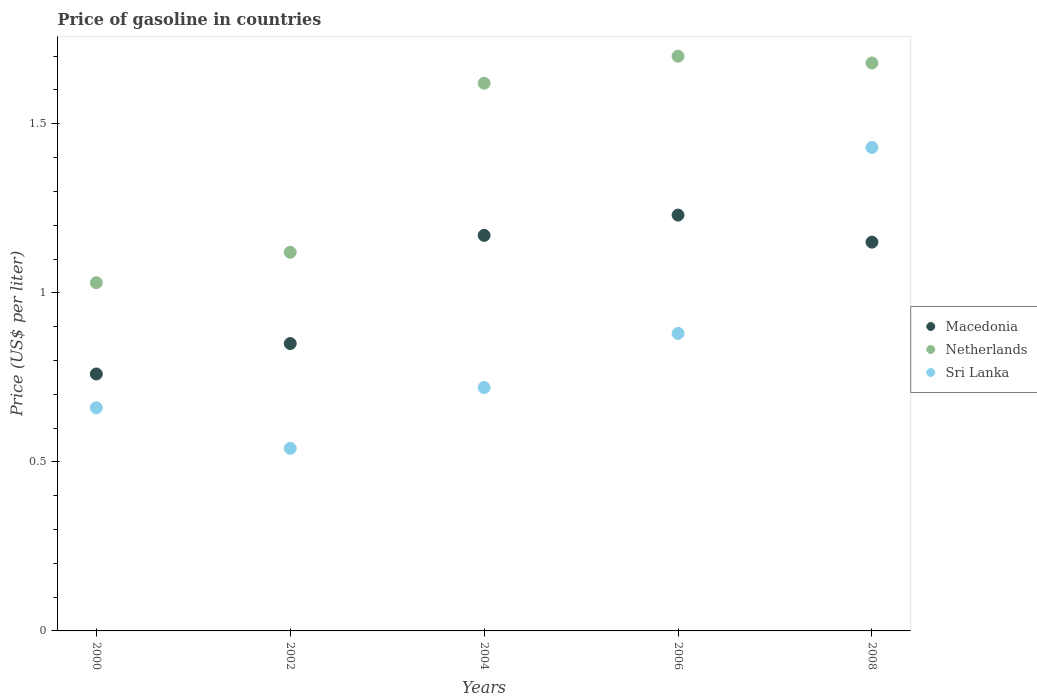What is the price of gasoline in Netherlands in 2000?
Offer a very short reply. 1.03. Across all years, what is the maximum price of gasoline in Netherlands?
Provide a short and direct response. 1.7. In which year was the price of gasoline in Netherlands maximum?
Provide a short and direct response. 2006. In which year was the price of gasoline in Netherlands minimum?
Give a very brief answer. 2000. What is the total price of gasoline in Netherlands in the graph?
Give a very brief answer. 7.15. What is the difference between the price of gasoline in Macedonia in 2002 and that in 2004?
Give a very brief answer. -0.32. What is the difference between the price of gasoline in Macedonia in 2002 and the price of gasoline in Sri Lanka in 2008?
Offer a terse response. -0.58. What is the average price of gasoline in Sri Lanka per year?
Offer a terse response. 0.85. In the year 2000, what is the difference between the price of gasoline in Macedonia and price of gasoline in Sri Lanka?
Provide a succinct answer. 0.1. In how many years, is the price of gasoline in Sri Lanka greater than 0.9 US$?
Keep it short and to the point. 1. What is the ratio of the price of gasoline in Macedonia in 2002 to that in 2008?
Make the answer very short. 0.74. Is the difference between the price of gasoline in Macedonia in 2000 and 2004 greater than the difference between the price of gasoline in Sri Lanka in 2000 and 2004?
Provide a short and direct response. No. What is the difference between the highest and the second highest price of gasoline in Macedonia?
Ensure brevity in your answer.  0.06. What is the difference between the highest and the lowest price of gasoline in Sri Lanka?
Ensure brevity in your answer.  0.89. Is the sum of the price of gasoline in Netherlands in 2000 and 2006 greater than the maximum price of gasoline in Sri Lanka across all years?
Offer a terse response. Yes. Is it the case that in every year, the sum of the price of gasoline in Sri Lanka and price of gasoline in Netherlands  is greater than the price of gasoline in Macedonia?
Make the answer very short. Yes. Does the price of gasoline in Sri Lanka monotonically increase over the years?
Your response must be concise. No. How many dotlines are there?
Provide a succinct answer. 3. Are the values on the major ticks of Y-axis written in scientific E-notation?
Offer a very short reply. No. Where does the legend appear in the graph?
Ensure brevity in your answer.  Center right. What is the title of the graph?
Your answer should be compact. Price of gasoline in countries. What is the label or title of the Y-axis?
Keep it short and to the point. Price (US$ per liter). What is the Price (US$ per liter) of Macedonia in 2000?
Your response must be concise. 0.76. What is the Price (US$ per liter) in Netherlands in 2000?
Keep it short and to the point. 1.03. What is the Price (US$ per liter) in Sri Lanka in 2000?
Ensure brevity in your answer.  0.66. What is the Price (US$ per liter) of Macedonia in 2002?
Provide a short and direct response. 0.85. What is the Price (US$ per liter) in Netherlands in 2002?
Keep it short and to the point. 1.12. What is the Price (US$ per liter) of Sri Lanka in 2002?
Give a very brief answer. 0.54. What is the Price (US$ per liter) in Macedonia in 2004?
Give a very brief answer. 1.17. What is the Price (US$ per liter) of Netherlands in 2004?
Ensure brevity in your answer.  1.62. What is the Price (US$ per liter) in Sri Lanka in 2004?
Provide a short and direct response. 0.72. What is the Price (US$ per liter) in Macedonia in 2006?
Make the answer very short. 1.23. What is the Price (US$ per liter) of Sri Lanka in 2006?
Make the answer very short. 0.88. What is the Price (US$ per liter) in Macedonia in 2008?
Keep it short and to the point. 1.15. What is the Price (US$ per liter) of Netherlands in 2008?
Offer a terse response. 1.68. What is the Price (US$ per liter) in Sri Lanka in 2008?
Give a very brief answer. 1.43. Across all years, what is the maximum Price (US$ per liter) of Macedonia?
Your answer should be very brief. 1.23. Across all years, what is the maximum Price (US$ per liter) of Sri Lanka?
Keep it short and to the point. 1.43. Across all years, what is the minimum Price (US$ per liter) of Macedonia?
Make the answer very short. 0.76. Across all years, what is the minimum Price (US$ per liter) of Sri Lanka?
Offer a very short reply. 0.54. What is the total Price (US$ per liter) of Macedonia in the graph?
Keep it short and to the point. 5.16. What is the total Price (US$ per liter) of Netherlands in the graph?
Your answer should be compact. 7.15. What is the total Price (US$ per liter) of Sri Lanka in the graph?
Your response must be concise. 4.23. What is the difference between the Price (US$ per liter) of Macedonia in 2000 and that in 2002?
Keep it short and to the point. -0.09. What is the difference between the Price (US$ per liter) in Netherlands in 2000 and that in 2002?
Give a very brief answer. -0.09. What is the difference between the Price (US$ per liter) in Sri Lanka in 2000 and that in 2002?
Offer a very short reply. 0.12. What is the difference between the Price (US$ per liter) of Macedonia in 2000 and that in 2004?
Your answer should be compact. -0.41. What is the difference between the Price (US$ per liter) of Netherlands in 2000 and that in 2004?
Your response must be concise. -0.59. What is the difference between the Price (US$ per liter) in Sri Lanka in 2000 and that in 2004?
Give a very brief answer. -0.06. What is the difference between the Price (US$ per liter) in Macedonia in 2000 and that in 2006?
Provide a succinct answer. -0.47. What is the difference between the Price (US$ per liter) in Netherlands in 2000 and that in 2006?
Provide a succinct answer. -0.67. What is the difference between the Price (US$ per liter) in Sri Lanka in 2000 and that in 2006?
Provide a short and direct response. -0.22. What is the difference between the Price (US$ per liter) in Macedonia in 2000 and that in 2008?
Keep it short and to the point. -0.39. What is the difference between the Price (US$ per liter) in Netherlands in 2000 and that in 2008?
Make the answer very short. -0.65. What is the difference between the Price (US$ per liter) of Sri Lanka in 2000 and that in 2008?
Make the answer very short. -0.77. What is the difference between the Price (US$ per liter) in Macedonia in 2002 and that in 2004?
Offer a terse response. -0.32. What is the difference between the Price (US$ per liter) of Sri Lanka in 2002 and that in 2004?
Offer a very short reply. -0.18. What is the difference between the Price (US$ per liter) in Macedonia in 2002 and that in 2006?
Offer a terse response. -0.38. What is the difference between the Price (US$ per liter) of Netherlands in 2002 and that in 2006?
Your answer should be very brief. -0.58. What is the difference between the Price (US$ per liter) in Sri Lanka in 2002 and that in 2006?
Your answer should be very brief. -0.34. What is the difference between the Price (US$ per liter) of Netherlands in 2002 and that in 2008?
Your answer should be compact. -0.56. What is the difference between the Price (US$ per liter) of Sri Lanka in 2002 and that in 2008?
Give a very brief answer. -0.89. What is the difference between the Price (US$ per liter) of Macedonia in 2004 and that in 2006?
Keep it short and to the point. -0.06. What is the difference between the Price (US$ per liter) in Netherlands in 2004 and that in 2006?
Provide a succinct answer. -0.08. What is the difference between the Price (US$ per liter) of Sri Lanka in 2004 and that in 2006?
Your answer should be compact. -0.16. What is the difference between the Price (US$ per liter) of Netherlands in 2004 and that in 2008?
Your answer should be very brief. -0.06. What is the difference between the Price (US$ per liter) in Sri Lanka in 2004 and that in 2008?
Your answer should be compact. -0.71. What is the difference between the Price (US$ per liter) of Macedonia in 2006 and that in 2008?
Offer a very short reply. 0.08. What is the difference between the Price (US$ per liter) in Netherlands in 2006 and that in 2008?
Your answer should be very brief. 0.02. What is the difference between the Price (US$ per liter) in Sri Lanka in 2006 and that in 2008?
Offer a very short reply. -0.55. What is the difference between the Price (US$ per liter) of Macedonia in 2000 and the Price (US$ per liter) of Netherlands in 2002?
Give a very brief answer. -0.36. What is the difference between the Price (US$ per liter) in Macedonia in 2000 and the Price (US$ per liter) in Sri Lanka in 2002?
Ensure brevity in your answer.  0.22. What is the difference between the Price (US$ per liter) in Netherlands in 2000 and the Price (US$ per liter) in Sri Lanka in 2002?
Make the answer very short. 0.49. What is the difference between the Price (US$ per liter) of Macedonia in 2000 and the Price (US$ per liter) of Netherlands in 2004?
Give a very brief answer. -0.86. What is the difference between the Price (US$ per liter) of Netherlands in 2000 and the Price (US$ per liter) of Sri Lanka in 2004?
Ensure brevity in your answer.  0.31. What is the difference between the Price (US$ per liter) of Macedonia in 2000 and the Price (US$ per liter) of Netherlands in 2006?
Ensure brevity in your answer.  -0.94. What is the difference between the Price (US$ per liter) in Macedonia in 2000 and the Price (US$ per liter) in Sri Lanka in 2006?
Offer a very short reply. -0.12. What is the difference between the Price (US$ per liter) of Macedonia in 2000 and the Price (US$ per liter) of Netherlands in 2008?
Offer a very short reply. -0.92. What is the difference between the Price (US$ per liter) in Macedonia in 2000 and the Price (US$ per liter) in Sri Lanka in 2008?
Make the answer very short. -0.67. What is the difference between the Price (US$ per liter) of Macedonia in 2002 and the Price (US$ per liter) of Netherlands in 2004?
Keep it short and to the point. -0.77. What is the difference between the Price (US$ per liter) in Macedonia in 2002 and the Price (US$ per liter) in Sri Lanka in 2004?
Make the answer very short. 0.13. What is the difference between the Price (US$ per liter) of Netherlands in 2002 and the Price (US$ per liter) of Sri Lanka in 2004?
Give a very brief answer. 0.4. What is the difference between the Price (US$ per liter) of Macedonia in 2002 and the Price (US$ per liter) of Netherlands in 2006?
Give a very brief answer. -0.85. What is the difference between the Price (US$ per liter) in Macedonia in 2002 and the Price (US$ per liter) in Sri Lanka in 2006?
Your answer should be compact. -0.03. What is the difference between the Price (US$ per liter) of Netherlands in 2002 and the Price (US$ per liter) of Sri Lanka in 2006?
Offer a terse response. 0.24. What is the difference between the Price (US$ per liter) of Macedonia in 2002 and the Price (US$ per liter) of Netherlands in 2008?
Your response must be concise. -0.83. What is the difference between the Price (US$ per liter) of Macedonia in 2002 and the Price (US$ per liter) of Sri Lanka in 2008?
Ensure brevity in your answer.  -0.58. What is the difference between the Price (US$ per liter) in Netherlands in 2002 and the Price (US$ per liter) in Sri Lanka in 2008?
Your response must be concise. -0.31. What is the difference between the Price (US$ per liter) in Macedonia in 2004 and the Price (US$ per liter) in Netherlands in 2006?
Ensure brevity in your answer.  -0.53. What is the difference between the Price (US$ per liter) in Macedonia in 2004 and the Price (US$ per liter) in Sri Lanka in 2006?
Make the answer very short. 0.29. What is the difference between the Price (US$ per liter) in Netherlands in 2004 and the Price (US$ per liter) in Sri Lanka in 2006?
Your answer should be very brief. 0.74. What is the difference between the Price (US$ per liter) in Macedonia in 2004 and the Price (US$ per liter) in Netherlands in 2008?
Offer a very short reply. -0.51. What is the difference between the Price (US$ per liter) in Macedonia in 2004 and the Price (US$ per liter) in Sri Lanka in 2008?
Your response must be concise. -0.26. What is the difference between the Price (US$ per liter) of Netherlands in 2004 and the Price (US$ per liter) of Sri Lanka in 2008?
Provide a succinct answer. 0.19. What is the difference between the Price (US$ per liter) in Macedonia in 2006 and the Price (US$ per liter) in Netherlands in 2008?
Your answer should be compact. -0.45. What is the difference between the Price (US$ per liter) in Netherlands in 2006 and the Price (US$ per liter) in Sri Lanka in 2008?
Offer a terse response. 0.27. What is the average Price (US$ per liter) in Macedonia per year?
Your response must be concise. 1.03. What is the average Price (US$ per liter) in Netherlands per year?
Provide a succinct answer. 1.43. What is the average Price (US$ per liter) in Sri Lanka per year?
Your answer should be very brief. 0.85. In the year 2000, what is the difference between the Price (US$ per liter) of Macedonia and Price (US$ per liter) of Netherlands?
Provide a short and direct response. -0.27. In the year 2000, what is the difference between the Price (US$ per liter) in Netherlands and Price (US$ per liter) in Sri Lanka?
Ensure brevity in your answer.  0.37. In the year 2002, what is the difference between the Price (US$ per liter) in Macedonia and Price (US$ per liter) in Netherlands?
Provide a succinct answer. -0.27. In the year 2002, what is the difference between the Price (US$ per liter) of Macedonia and Price (US$ per liter) of Sri Lanka?
Provide a short and direct response. 0.31. In the year 2002, what is the difference between the Price (US$ per liter) of Netherlands and Price (US$ per liter) of Sri Lanka?
Provide a succinct answer. 0.58. In the year 2004, what is the difference between the Price (US$ per liter) in Macedonia and Price (US$ per liter) in Netherlands?
Your answer should be compact. -0.45. In the year 2004, what is the difference between the Price (US$ per liter) of Macedonia and Price (US$ per liter) of Sri Lanka?
Give a very brief answer. 0.45. In the year 2006, what is the difference between the Price (US$ per liter) of Macedonia and Price (US$ per liter) of Netherlands?
Your answer should be very brief. -0.47. In the year 2006, what is the difference between the Price (US$ per liter) in Netherlands and Price (US$ per liter) in Sri Lanka?
Provide a short and direct response. 0.82. In the year 2008, what is the difference between the Price (US$ per liter) of Macedonia and Price (US$ per liter) of Netherlands?
Provide a succinct answer. -0.53. In the year 2008, what is the difference between the Price (US$ per liter) in Macedonia and Price (US$ per liter) in Sri Lanka?
Make the answer very short. -0.28. In the year 2008, what is the difference between the Price (US$ per liter) of Netherlands and Price (US$ per liter) of Sri Lanka?
Keep it short and to the point. 0.25. What is the ratio of the Price (US$ per liter) of Macedonia in 2000 to that in 2002?
Your response must be concise. 0.89. What is the ratio of the Price (US$ per liter) of Netherlands in 2000 to that in 2002?
Make the answer very short. 0.92. What is the ratio of the Price (US$ per liter) in Sri Lanka in 2000 to that in 2002?
Make the answer very short. 1.22. What is the ratio of the Price (US$ per liter) in Macedonia in 2000 to that in 2004?
Your response must be concise. 0.65. What is the ratio of the Price (US$ per liter) in Netherlands in 2000 to that in 2004?
Give a very brief answer. 0.64. What is the ratio of the Price (US$ per liter) of Sri Lanka in 2000 to that in 2004?
Keep it short and to the point. 0.92. What is the ratio of the Price (US$ per liter) in Macedonia in 2000 to that in 2006?
Make the answer very short. 0.62. What is the ratio of the Price (US$ per liter) of Netherlands in 2000 to that in 2006?
Your answer should be very brief. 0.61. What is the ratio of the Price (US$ per liter) of Sri Lanka in 2000 to that in 2006?
Your answer should be very brief. 0.75. What is the ratio of the Price (US$ per liter) of Macedonia in 2000 to that in 2008?
Your response must be concise. 0.66. What is the ratio of the Price (US$ per liter) of Netherlands in 2000 to that in 2008?
Provide a short and direct response. 0.61. What is the ratio of the Price (US$ per liter) of Sri Lanka in 2000 to that in 2008?
Ensure brevity in your answer.  0.46. What is the ratio of the Price (US$ per liter) of Macedonia in 2002 to that in 2004?
Your answer should be compact. 0.73. What is the ratio of the Price (US$ per liter) of Netherlands in 2002 to that in 2004?
Give a very brief answer. 0.69. What is the ratio of the Price (US$ per liter) in Macedonia in 2002 to that in 2006?
Your answer should be compact. 0.69. What is the ratio of the Price (US$ per liter) of Netherlands in 2002 to that in 2006?
Offer a terse response. 0.66. What is the ratio of the Price (US$ per liter) of Sri Lanka in 2002 to that in 2006?
Offer a terse response. 0.61. What is the ratio of the Price (US$ per liter) in Macedonia in 2002 to that in 2008?
Your answer should be compact. 0.74. What is the ratio of the Price (US$ per liter) of Netherlands in 2002 to that in 2008?
Provide a short and direct response. 0.67. What is the ratio of the Price (US$ per liter) in Sri Lanka in 2002 to that in 2008?
Your answer should be compact. 0.38. What is the ratio of the Price (US$ per liter) of Macedonia in 2004 to that in 2006?
Give a very brief answer. 0.95. What is the ratio of the Price (US$ per liter) of Netherlands in 2004 to that in 2006?
Offer a terse response. 0.95. What is the ratio of the Price (US$ per liter) of Sri Lanka in 2004 to that in 2006?
Your answer should be compact. 0.82. What is the ratio of the Price (US$ per liter) in Macedonia in 2004 to that in 2008?
Your response must be concise. 1.02. What is the ratio of the Price (US$ per liter) in Netherlands in 2004 to that in 2008?
Give a very brief answer. 0.96. What is the ratio of the Price (US$ per liter) of Sri Lanka in 2004 to that in 2008?
Ensure brevity in your answer.  0.5. What is the ratio of the Price (US$ per liter) of Macedonia in 2006 to that in 2008?
Ensure brevity in your answer.  1.07. What is the ratio of the Price (US$ per liter) in Netherlands in 2006 to that in 2008?
Your response must be concise. 1.01. What is the ratio of the Price (US$ per liter) of Sri Lanka in 2006 to that in 2008?
Ensure brevity in your answer.  0.62. What is the difference between the highest and the second highest Price (US$ per liter) in Macedonia?
Make the answer very short. 0.06. What is the difference between the highest and the second highest Price (US$ per liter) in Sri Lanka?
Provide a short and direct response. 0.55. What is the difference between the highest and the lowest Price (US$ per liter) of Macedonia?
Provide a short and direct response. 0.47. What is the difference between the highest and the lowest Price (US$ per liter) of Netherlands?
Make the answer very short. 0.67. What is the difference between the highest and the lowest Price (US$ per liter) of Sri Lanka?
Give a very brief answer. 0.89. 